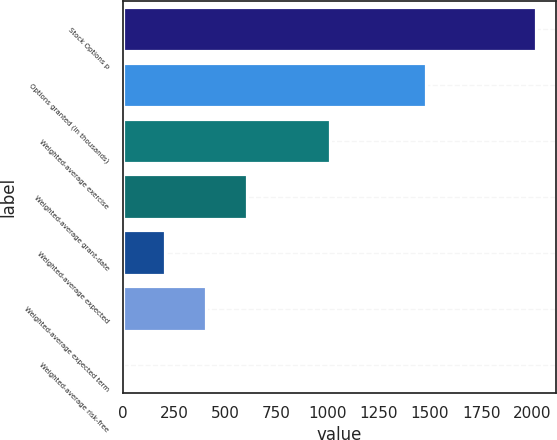<chart> <loc_0><loc_0><loc_500><loc_500><bar_chart><fcel>Stock Options p<fcel>Options granted (in thousands)<fcel>Weighted-average exercise<fcel>Weighted-average grant-date<fcel>Weighted-average expected<fcel>Weighted-average expected term<fcel>Weighted-average risk-free<nl><fcel>2017<fcel>1480<fcel>1009.55<fcel>606.57<fcel>203.59<fcel>405.08<fcel>2.1<nl></chart> 